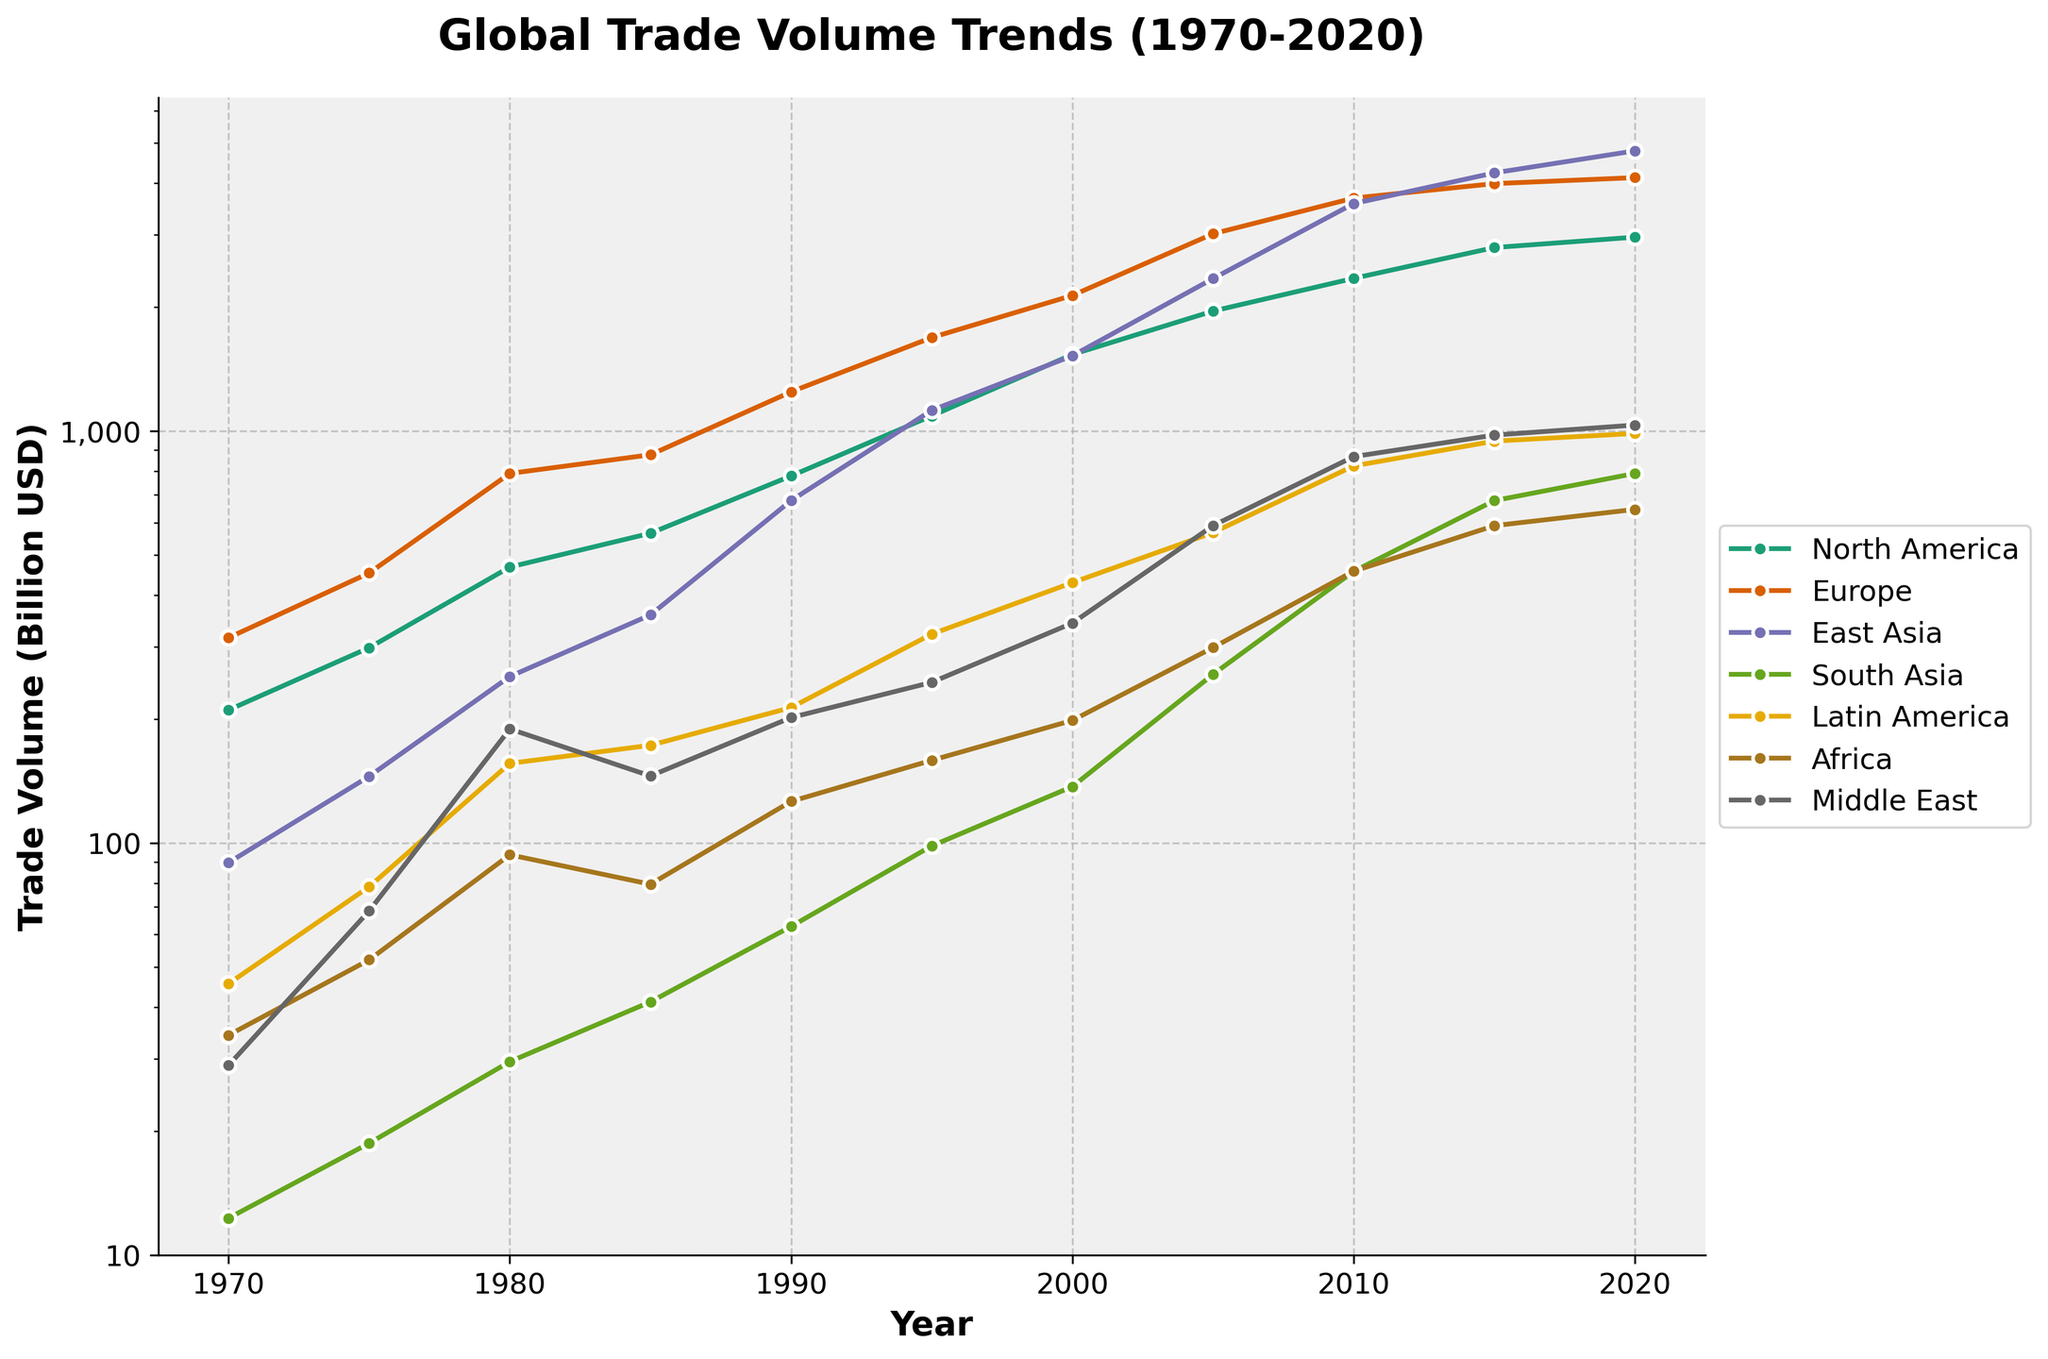What is the overall trend of global trade volume for East Asia from 1970 to 2020? The plot shows an increasing trend for East Asia's trade volume over the years, starting from 89.7 billion USD in 1970 and reaching 4789.2 billion USD in 2020, indicating significant growth.
Answer: Increasing Which economic region had the highest trade volume in 2020? By observing the highest point on the plot for 2020, East Asia had the highest trade volume among all regions with 4789.2 billion USD.
Answer: East Asia By how many billion USD did Latin America's trade volume increase from 1970 to 2020? Latin America had a trade volume of 45.6 billion USD in 1970 and 987.3 billion USD in 2020. The increase is calculated as 987.3 - 45.6 = 941.7 billion USD.
Answer: 941.7 billion USD Which region had the fastest growth rate in trade volume between 1970 and 2020 relative to its initial value? To find the fastest growth rate relative to the initial value, we can calculate the relative growth for each region: (North America: 2956.8 / 210.5), (Europe: 4123.7 / 315.2), (East Asia: 4789.2 / 89.7), (South Asia: 789.5 / 12.3), (Latin America: 987.3 / 45.6), (Africa: 645.8 / 34.2), (Middle East: 1034.6 / 28.9). By comparing the growth rates, South Asia has the highest relative increase.
Answer: South Asia What is the approximate year where East Asia's trade volume surpassed Europe's? Observing the intersection points of the lines for East Asia and Europe shows that East Asia's trade volume surpassed Europe around the year 2010.
Answer: Near 2010 By what factor did North America's trade volume increase from 1980 to 2000? How about Europe in the same period? North America's trade volume in 1980 was 467.9 billion USD and in 2000 was 1534.7 billion USD, so the factor of increase is 1534.7 / 467.9 ≈ 3.28. Europe's trade volume in 1980 was 789.4 billion USD and in 2000 was 2134.5 billion USD, so the factor of increase is 2134.5 / 789.4 ≈ 2.70.
Answer: North America: 3.28, Europe: 2.70 Which region showed a significant trade volume jump between 2000 and 2010, and how much was the increase? By observing the plot, East Asia showed a significant jump in trade volume between 2000 and 2010, increasing from 1523.8 billion USD to 3567.2 billion USD. The increase is calculated as 3567.2 - 1523.8 = 2043.4 billion USD.
Answer: East Asia, 2043.4 billion USD In the year 1995, which region had twice the trade volume of South Asia? South Asia's trade volume in 1995 was 98.5 billion USD. The region with twice the trade volume is approximately 98.5 * 2 = 197.0 billion USD. Observing the plot, North America (1089.3), Europe (1687.2), East Asia (1123.6), and Latin America (321.7) all had much higher trade volumes. None are exactly twice but multiple regions exceeded twice.
Answer: Multiple regions Compare the trade volume of Africa and the Middle East in 1980. Which region had a higher trade volume and by how much? In 1980, Africa's trade volume was 93.7 billion USD and the Middle East's was 189.3 billion USD. The Middle East had a higher trade volume by 189.3 - 93.7 = 95.6 billion USD.
Answer: Middle East, 95.6 billion USD 